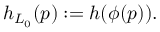Convert formula to latex. <formula><loc_0><loc_0><loc_500><loc_500>h _ { L _ { 0 } } ( p ) \colon = h ( \phi ( p ) ) .</formula> 